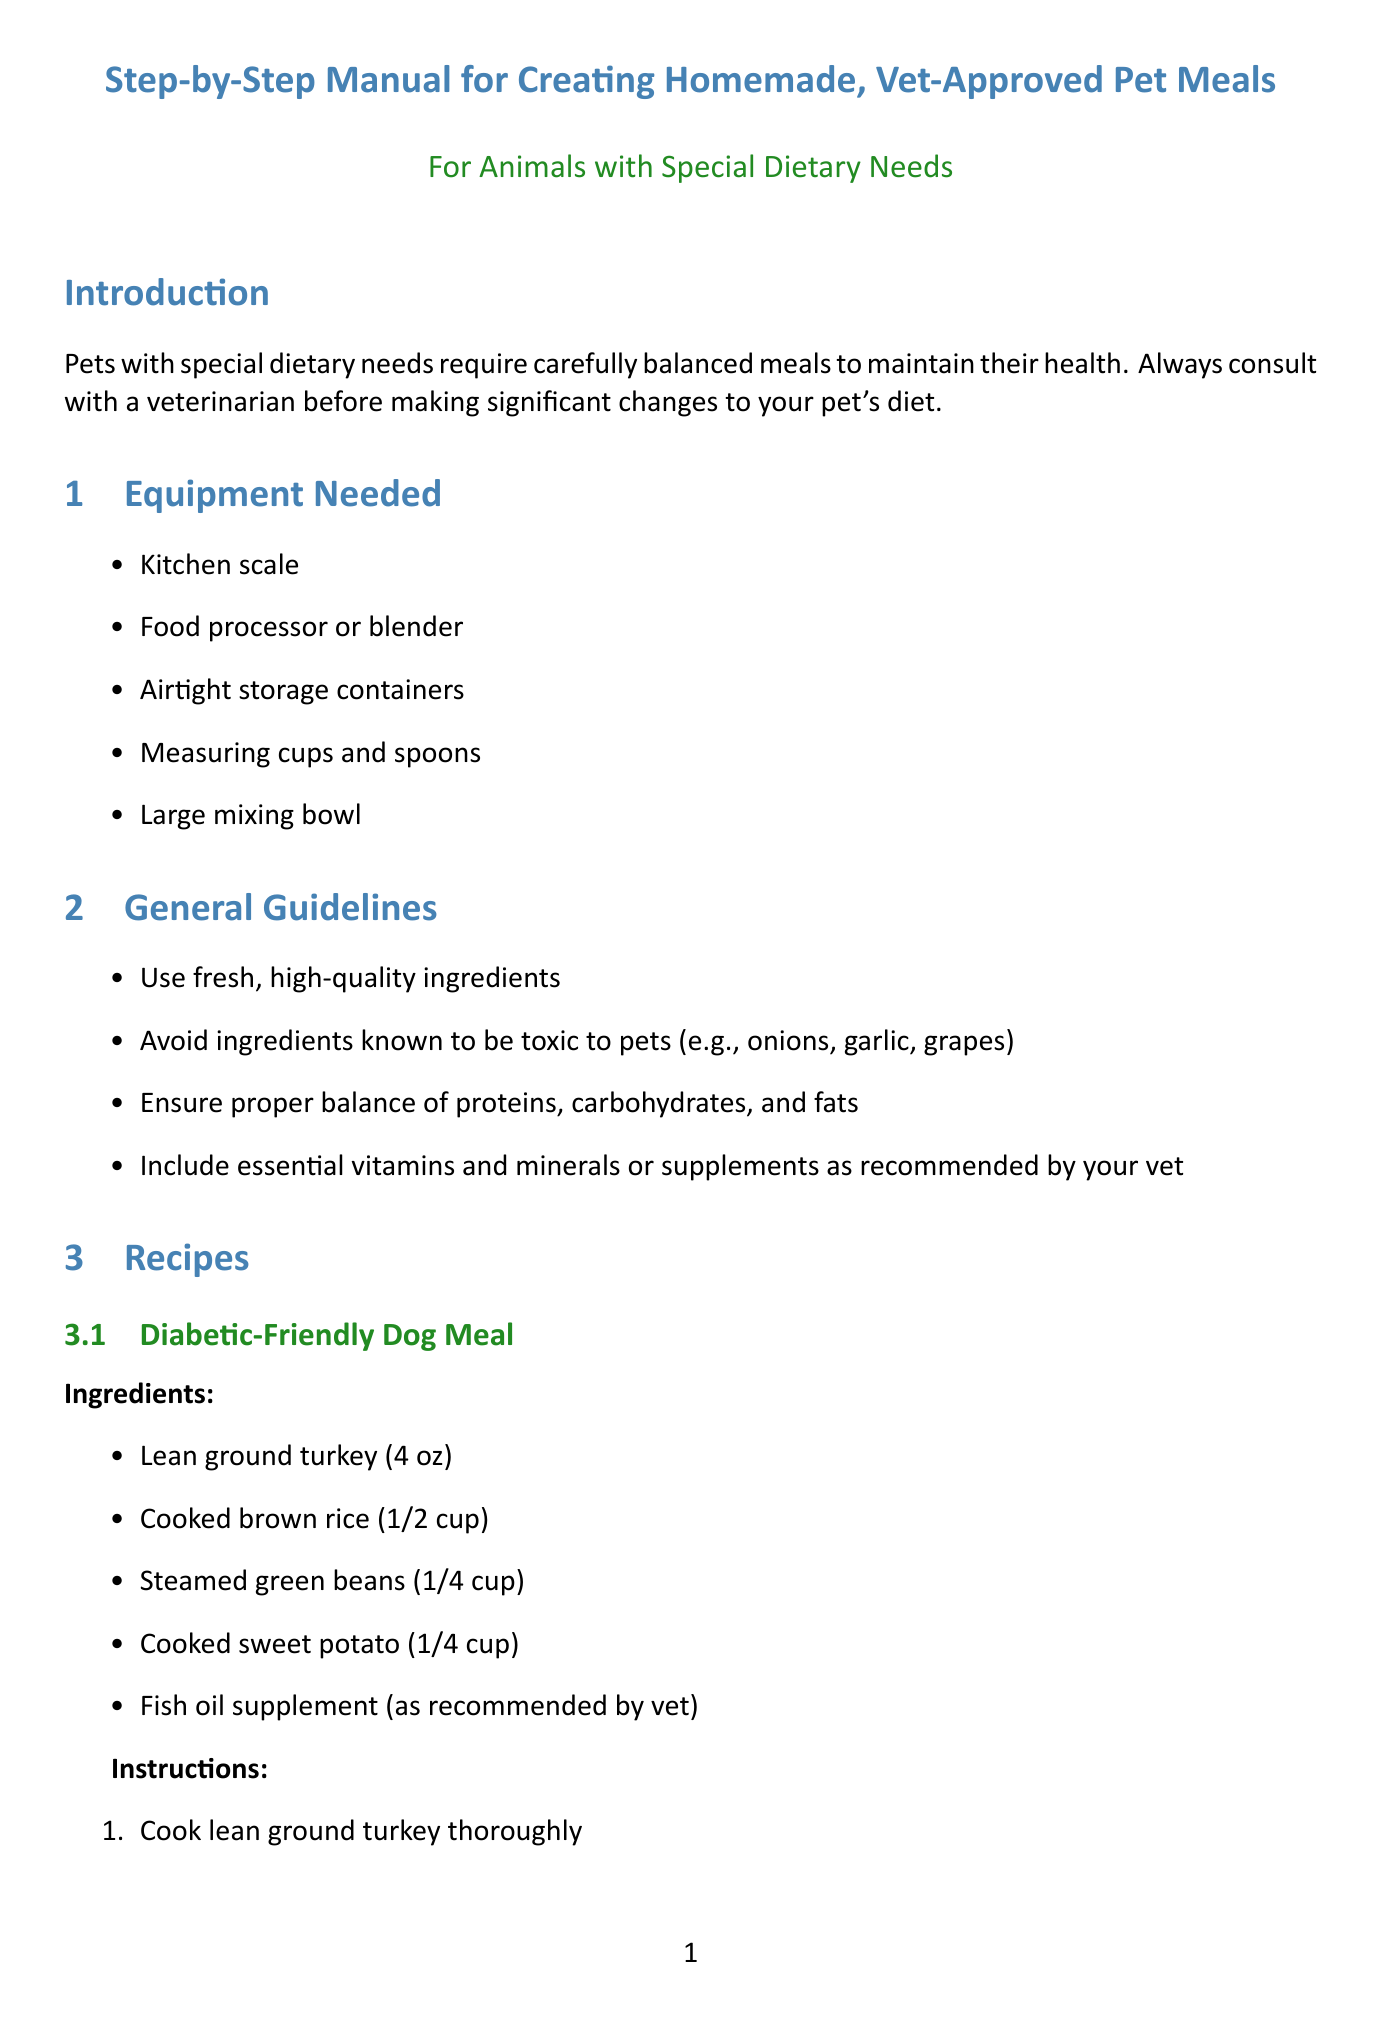what is the title of the manual? The title of the manual is clearly stated at the top, "Step-by-Step Manual for Creating Homemade, Vet-Approved Pet Meals for Animals with Special Dietary Needs."
Answer: Step-by-Step Manual for Creating Homemade, Vet-Approved Pet Meals for Animals with Special Dietary Needs how many recipes are included in the document? The document lists two specific recipes for special dietary needs, which can be counted.
Answer: 2 what is the first ingredient in the Diabetic-Friendly Dog Meal? The first ingredient listed under the Diabetic-Friendly Dog Meal is "Lean ground turkey."
Answer: Lean ground turkey what equipment is needed for creating homemade pet meals? The document provides a list of essential equipment needed for meal preparation, starting with the kitchen scale.
Answer: Kitchen scale what is the recommended portion control guideline? The guidelines state that portion control is crucial for managing weight and blood sugar levels in diabetic pets, emphasizing accurate measurement.
Answer: Use a kitchen scale to measure ingredients accurately which brand offers a fish oil supplement for overall health? The document specifies that Nordic Naturals offers a fish oil supplement for pets.
Answer: Nordic Naturals what is the nutritional benefit of the Kidney-Friendly Cat Meal? The document mentions low phosphorus ingredients supporting kidney function and adequate protein.
Answer: Low phosphorus ingredients to support kidney function why is it important to consult a veterinarian before changing a pet's diet? The introduction clearly states that consultation with a veterinarian is critical for making significant dietary changes for pet health.
Answer: To ensure health and safety what is the storage recommendation for prepared meals? The document states that prepared meals should be stored in airtight containers for a specific time.
Answer: Store prepared meals in airtight containers in the refrigerator for up to 3 days 